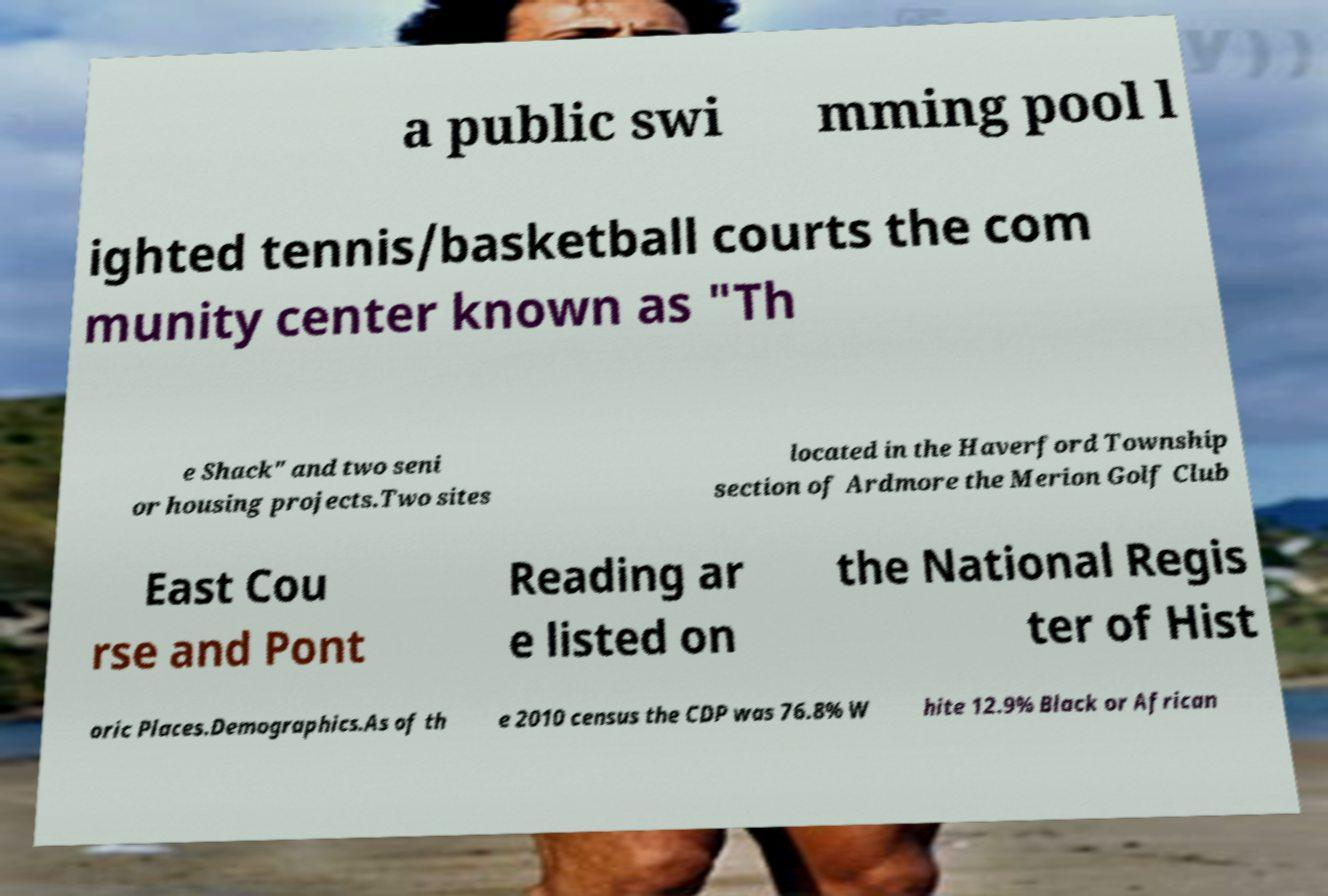There's text embedded in this image that I need extracted. Can you transcribe it verbatim? a public swi mming pool l ighted tennis/basketball courts the com munity center known as "Th e Shack" and two seni or housing projects.Two sites located in the Haverford Township section of Ardmore the Merion Golf Club East Cou rse and Pont Reading ar e listed on the National Regis ter of Hist oric Places.Demographics.As of th e 2010 census the CDP was 76.8% W hite 12.9% Black or African 